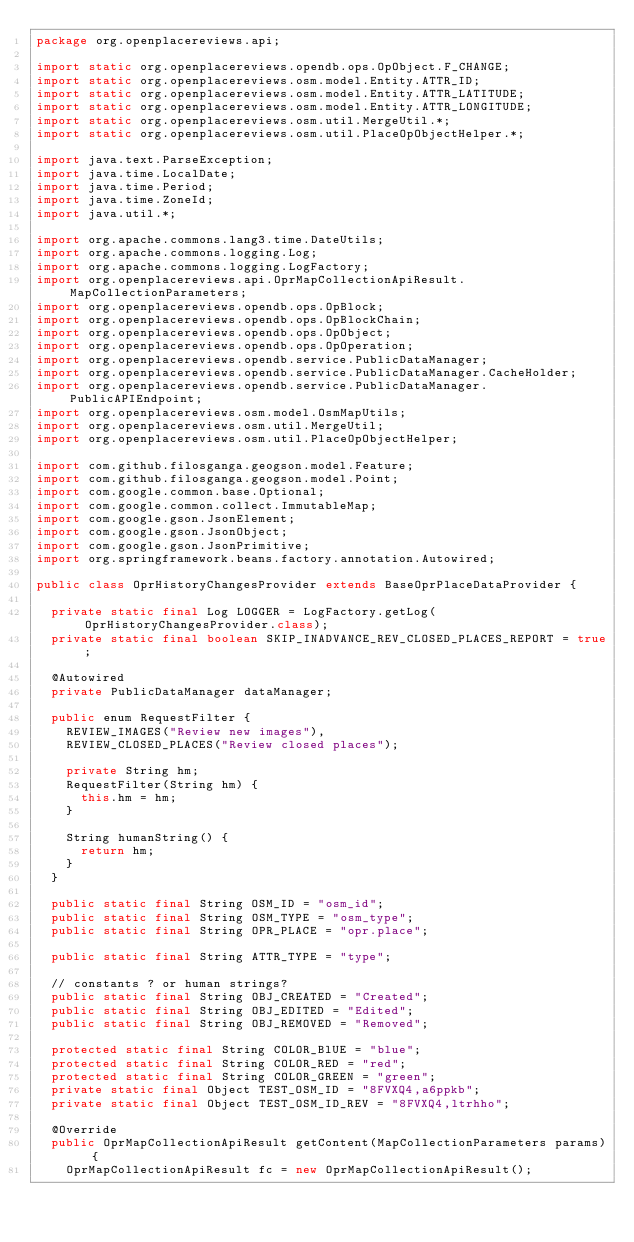Convert code to text. <code><loc_0><loc_0><loc_500><loc_500><_Java_>package org.openplacereviews.api;

import static org.openplacereviews.opendb.ops.OpObject.F_CHANGE;
import static org.openplacereviews.osm.model.Entity.ATTR_ID;
import static org.openplacereviews.osm.model.Entity.ATTR_LATITUDE;
import static org.openplacereviews.osm.model.Entity.ATTR_LONGITUDE;
import static org.openplacereviews.osm.util.MergeUtil.*;
import static org.openplacereviews.osm.util.PlaceOpObjectHelper.*;

import java.text.ParseException;
import java.time.LocalDate;
import java.time.Period;
import java.time.ZoneId;
import java.util.*;

import org.apache.commons.lang3.time.DateUtils;
import org.apache.commons.logging.Log;
import org.apache.commons.logging.LogFactory;
import org.openplacereviews.api.OprMapCollectionApiResult.MapCollectionParameters;
import org.openplacereviews.opendb.ops.OpBlock;
import org.openplacereviews.opendb.ops.OpBlockChain;
import org.openplacereviews.opendb.ops.OpObject;
import org.openplacereviews.opendb.ops.OpOperation;
import org.openplacereviews.opendb.service.PublicDataManager;
import org.openplacereviews.opendb.service.PublicDataManager.CacheHolder;
import org.openplacereviews.opendb.service.PublicDataManager.PublicAPIEndpoint;
import org.openplacereviews.osm.model.OsmMapUtils;
import org.openplacereviews.osm.util.MergeUtil;
import org.openplacereviews.osm.util.PlaceOpObjectHelper;

import com.github.filosganga.geogson.model.Feature;
import com.github.filosganga.geogson.model.Point;
import com.google.common.base.Optional;
import com.google.common.collect.ImmutableMap;
import com.google.gson.JsonElement;
import com.google.gson.JsonObject;
import com.google.gson.JsonPrimitive;
import org.springframework.beans.factory.annotation.Autowired;

public class OprHistoryChangesProvider extends BaseOprPlaceDataProvider {

	private static final Log LOGGER = LogFactory.getLog(OprHistoryChangesProvider.class);
	private static final boolean SKIP_INADVANCE_REV_CLOSED_PLACES_REPORT = true;

	@Autowired
	private PublicDataManager dataManager;
	
	public enum RequestFilter {
		REVIEW_IMAGES("Review new images"),
		REVIEW_CLOSED_PLACES("Review closed places");
		
		private String hm;
		RequestFilter(String hm) {
			this.hm = hm;
		}
		
		String humanString() {
			return hm;
		}
	}

	public static final String OSM_ID = "osm_id";
	public static final String OSM_TYPE = "osm_type";
	public static final String OPR_PLACE = "opr.place";

	public static final String ATTR_TYPE = "type";

	// constants ? or human strings?
	public static final String OBJ_CREATED = "Created";
	public static final String OBJ_EDITED = "Edited";
	public static final String OBJ_REMOVED = "Removed";
	
	protected static final String COLOR_BlUE = "blue";
	protected static final String COLOR_RED = "red";
	protected static final String COLOR_GREEN = "green";
	private static final Object TEST_OSM_ID = "8FVXQ4,a6ppkb";
	private static final Object TEST_OSM_ID_REV = "8FVXQ4,ltrhho";
	
	@Override
	public OprMapCollectionApiResult getContent(MapCollectionParameters params) {
		OprMapCollectionApiResult fc = new OprMapCollectionApiResult();</code> 